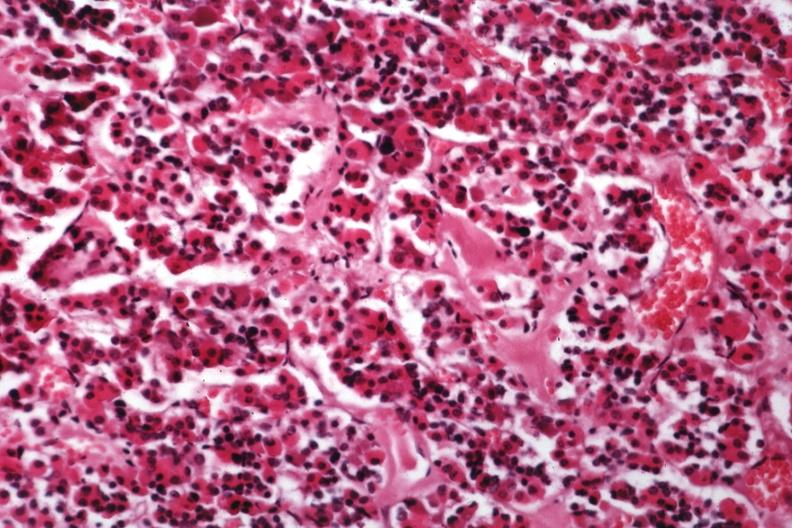what does this image show?
Answer the question using a single word or phrase. Hyalin material in pituitary which is amyloid 